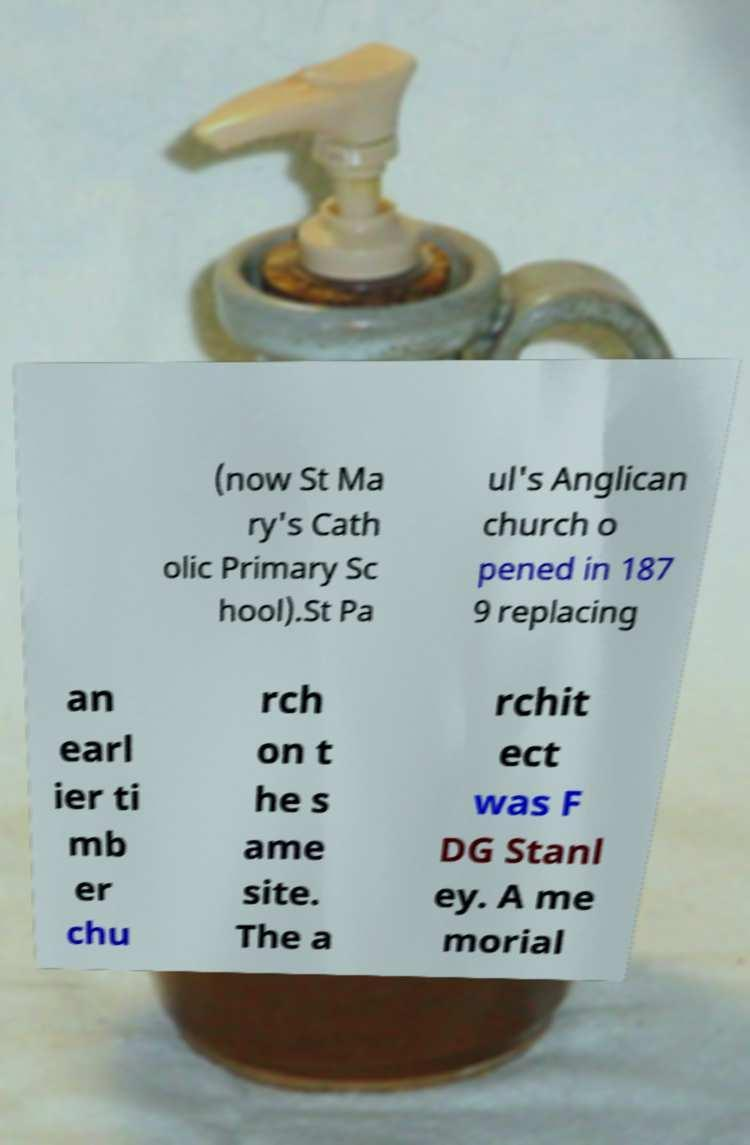There's text embedded in this image that I need extracted. Can you transcribe it verbatim? (now St Ma ry's Cath olic Primary Sc hool).St Pa ul's Anglican church o pened in 187 9 replacing an earl ier ti mb er chu rch on t he s ame site. The a rchit ect was F DG Stanl ey. A me morial 